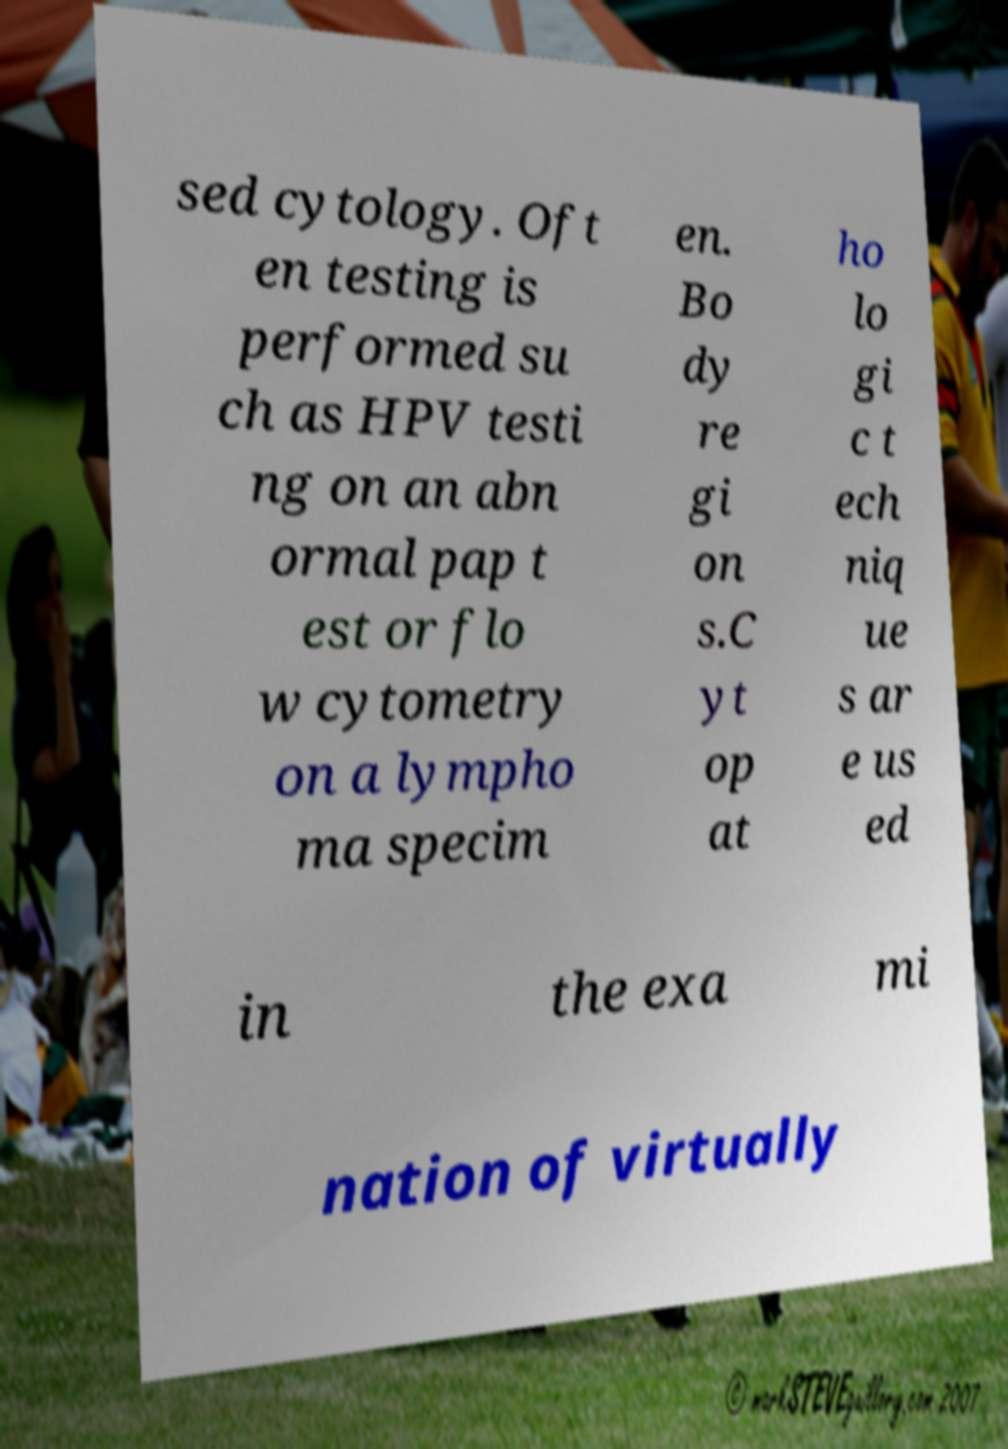What messages or text are displayed in this image? I need them in a readable, typed format. sed cytology. Oft en testing is performed su ch as HPV testi ng on an abn ormal pap t est or flo w cytometry on a lympho ma specim en. Bo dy re gi on s.C yt op at ho lo gi c t ech niq ue s ar e us ed in the exa mi nation of virtually 